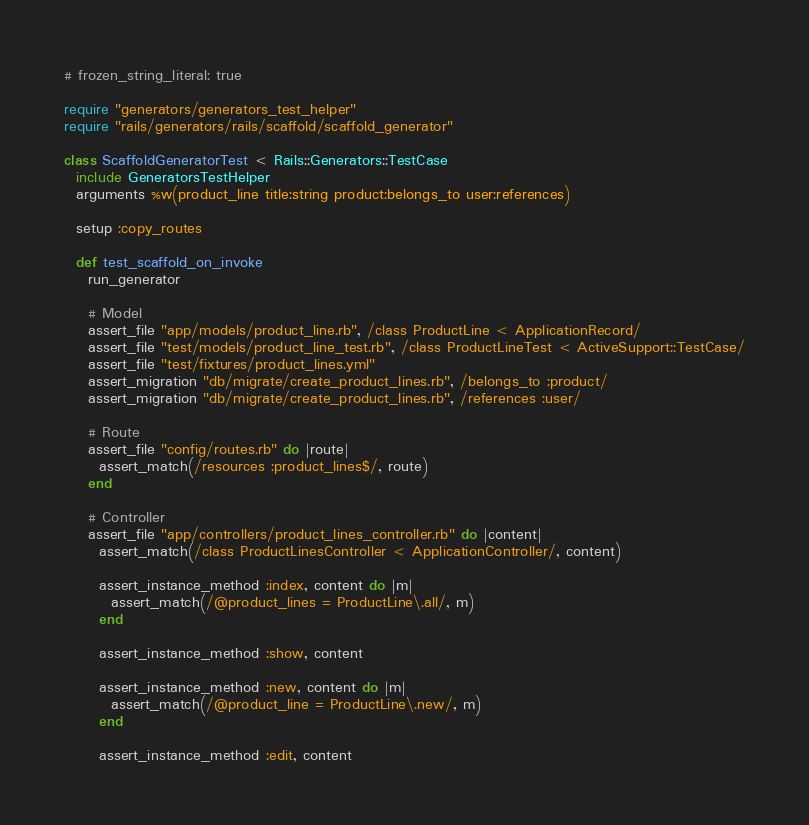Convert code to text. <code><loc_0><loc_0><loc_500><loc_500><_Ruby_># frozen_string_literal: true

require "generators/generators_test_helper"
require "rails/generators/rails/scaffold/scaffold_generator"

class ScaffoldGeneratorTest < Rails::Generators::TestCase
  include GeneratorsTestHelper
  arguments %w(product_line title:string product:belongs_to user:references)

  setup :copy_routes

  def test_scaffold_on_invoke
    run_generator

    # Model
    assert_file "app/models/product_line.rb", /class ProductLine < ApplicationRecord/
    assert_file "test/models/product_line_test.rb", /class ProductLineTest < ActiveSupport::TestCase/
    assert_file "test/fixtures/product_lines.yml"
    assert_migration "db/migrate/create_product_lines.rb", /belongs_to :product/
    assert_migration "db/migrate/create_product_lines.rb", /references :user/

    # Route
    assert_file "config/routes.rb" do |route|
      assert_match(/resources :product_lines$/, route)
    end

    # Controller
    assert_file "app/controllers/product_lines_controller.rb" do |content|
      assert_match(/class ProductLinesController < ApplicationController/, content)

      assert_instance_method :index, content do |m|
        assert_match(/@product_lines = ProductLine\.all/, m)
      end

      assert_instance_method :show, content

      assert_instance_method :new, content do |m|
        assert_match(/@product_line = ProductLine\.new/, m)
      end

      assert_instance_method :edit, content
</code> 